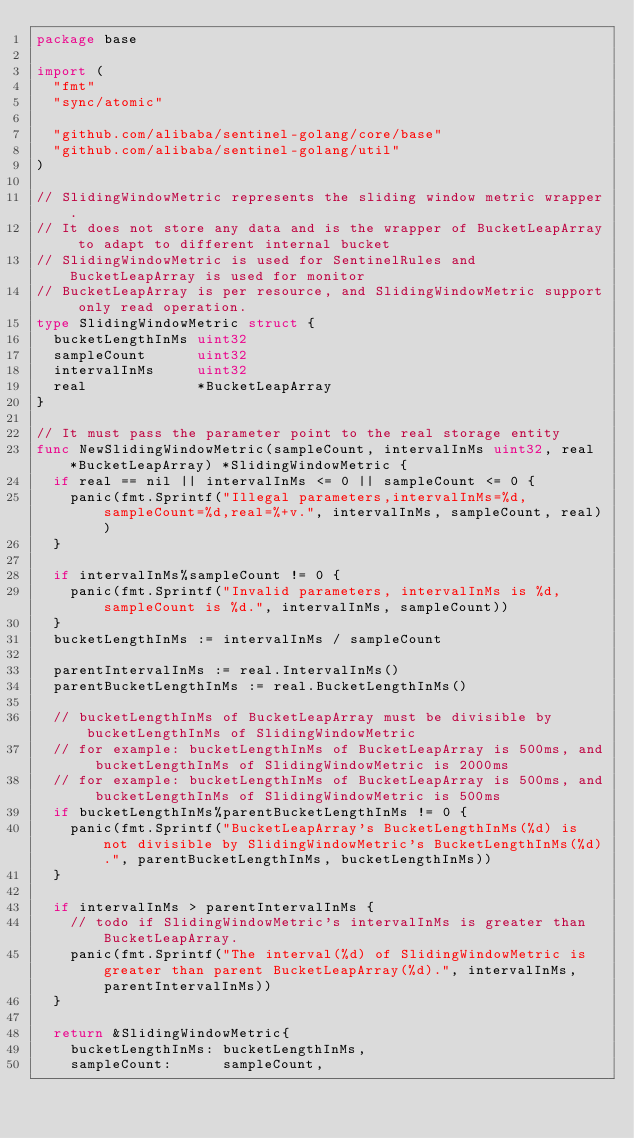<code> <loc_0><loc_0><loc_500><loc_500><_Go_>package base

import (
	"fmt"
	"sync/atomic"

	"github.com/alibaba/sentinel-golang/core/base"
	"github.com/alibaba/sentinel-golang/util"
)

// SlidingWindowMetric represents the sliding window metric wrapper.
// It does not store any data and is the wrapper of BucketLeapArray to adapt to different internal bucket
// SlidingWindowMetric is used for SentinelRules and BucketLeapArray is used for monitor
// BucketLeapArray is per resource, and SlidingWindowMetric support only read operation.
type SlidingWindowMetric struct {
	bucketLengthInMs uint32
	sampleCount      uint32
	intervalInMs     uint32
	real             *BucketLeapArray
}

// It must pass the parameter point to the real storage entity
func NewSlidingWindowMetric(sampleCount, intervalInMs uint32, real *BucketLeapArray) *SlidingWindowMetric {
	if real == nil || intervalInMs <= 0 || sampleCount <= 0 {
		panic(fmt.Sprintf("Illegal parameters,intervalInMs=%d,sampleCount=%d,real=%+v.", intervalInMs, sampleCount, real))
	}

	if intervalInMs%sampleCount != 0 {
		panic(fmt.Sprintf("Invalid parameters, intervalInMs is %d, sampleCount is %d.", intervalInMs, sampleCount))
	}
	bucketLengthInMs := intervalInMs / sampleCount

	parentIntervalInMs := real.IntervalInMs()
	parentBucketLengthInMs := real.BucketLengthInMs()

	// bucketLengthInMs of BucketLeapArray must be divisible by bucketLengthInMs of SlidingWindowMetric
	// for example: bucketLengthInMs of BucketLeapArray is 500ms, and bucketLengthInMs of SlidingWindowMetric is 2000ms
	// for example: bucketLengthInMs of BucketLeapArray is 500ms, and bucketLengthInMs of SlidingWindowMetric is 500ms
	if bucketLengthInMs%parentBucketLengthInMs != 0 {
		panic(fmt.Sprintf("BucketLeapArray's BucketLengthInMs(%d) is not divisible by SlidingWindowMetric's BucketLengthInMs(%d).", parentBucketLengthInMs, bucketLengthInMs))
	}

	if intervalInMs > parentIntervalInMs {
		// todo if SlidingWindowMetric's intervalInMs is greater than BucketLeapArray.
		panic(fmt.Sprintf("The interval(%d) of SlidingWindowMetric is greater than parent BucketLeapArray(%d).", intervalInMs, parentIntervalInMs))
	}

	return &SlidingWindowMetric{
		bucketLengthInMs: bucketLengthInMs,
		sampleCount:      sampleCount,</code> 